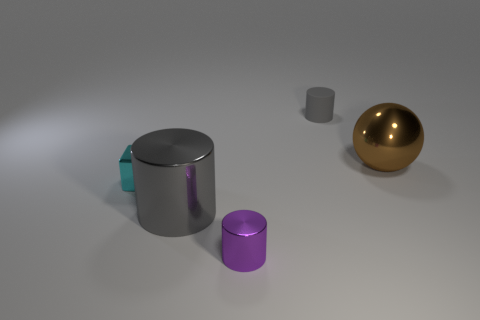Subtract all small gray cylinders. How many cylinders are left? 2 Subtract all yellow cylinders. Subtract all yellow cubes. How many cylinders are left? 3 Add 4 metallic cylinders. How many objects exist? 9 Subtract 1 purple cylinders. How many objects are left? 4 Subtract all blocks. How many objects are left? 4 Subtract all tiny purple cylinders. Subtract all gray metal objects. How many objects are left? 3 Add 1 tiny cyan shiny cubes. How many tiny cyan shiny cubes are left? 2 Add 2 tiny matte cylinders. How many tiny matte cylinders exist? 3 